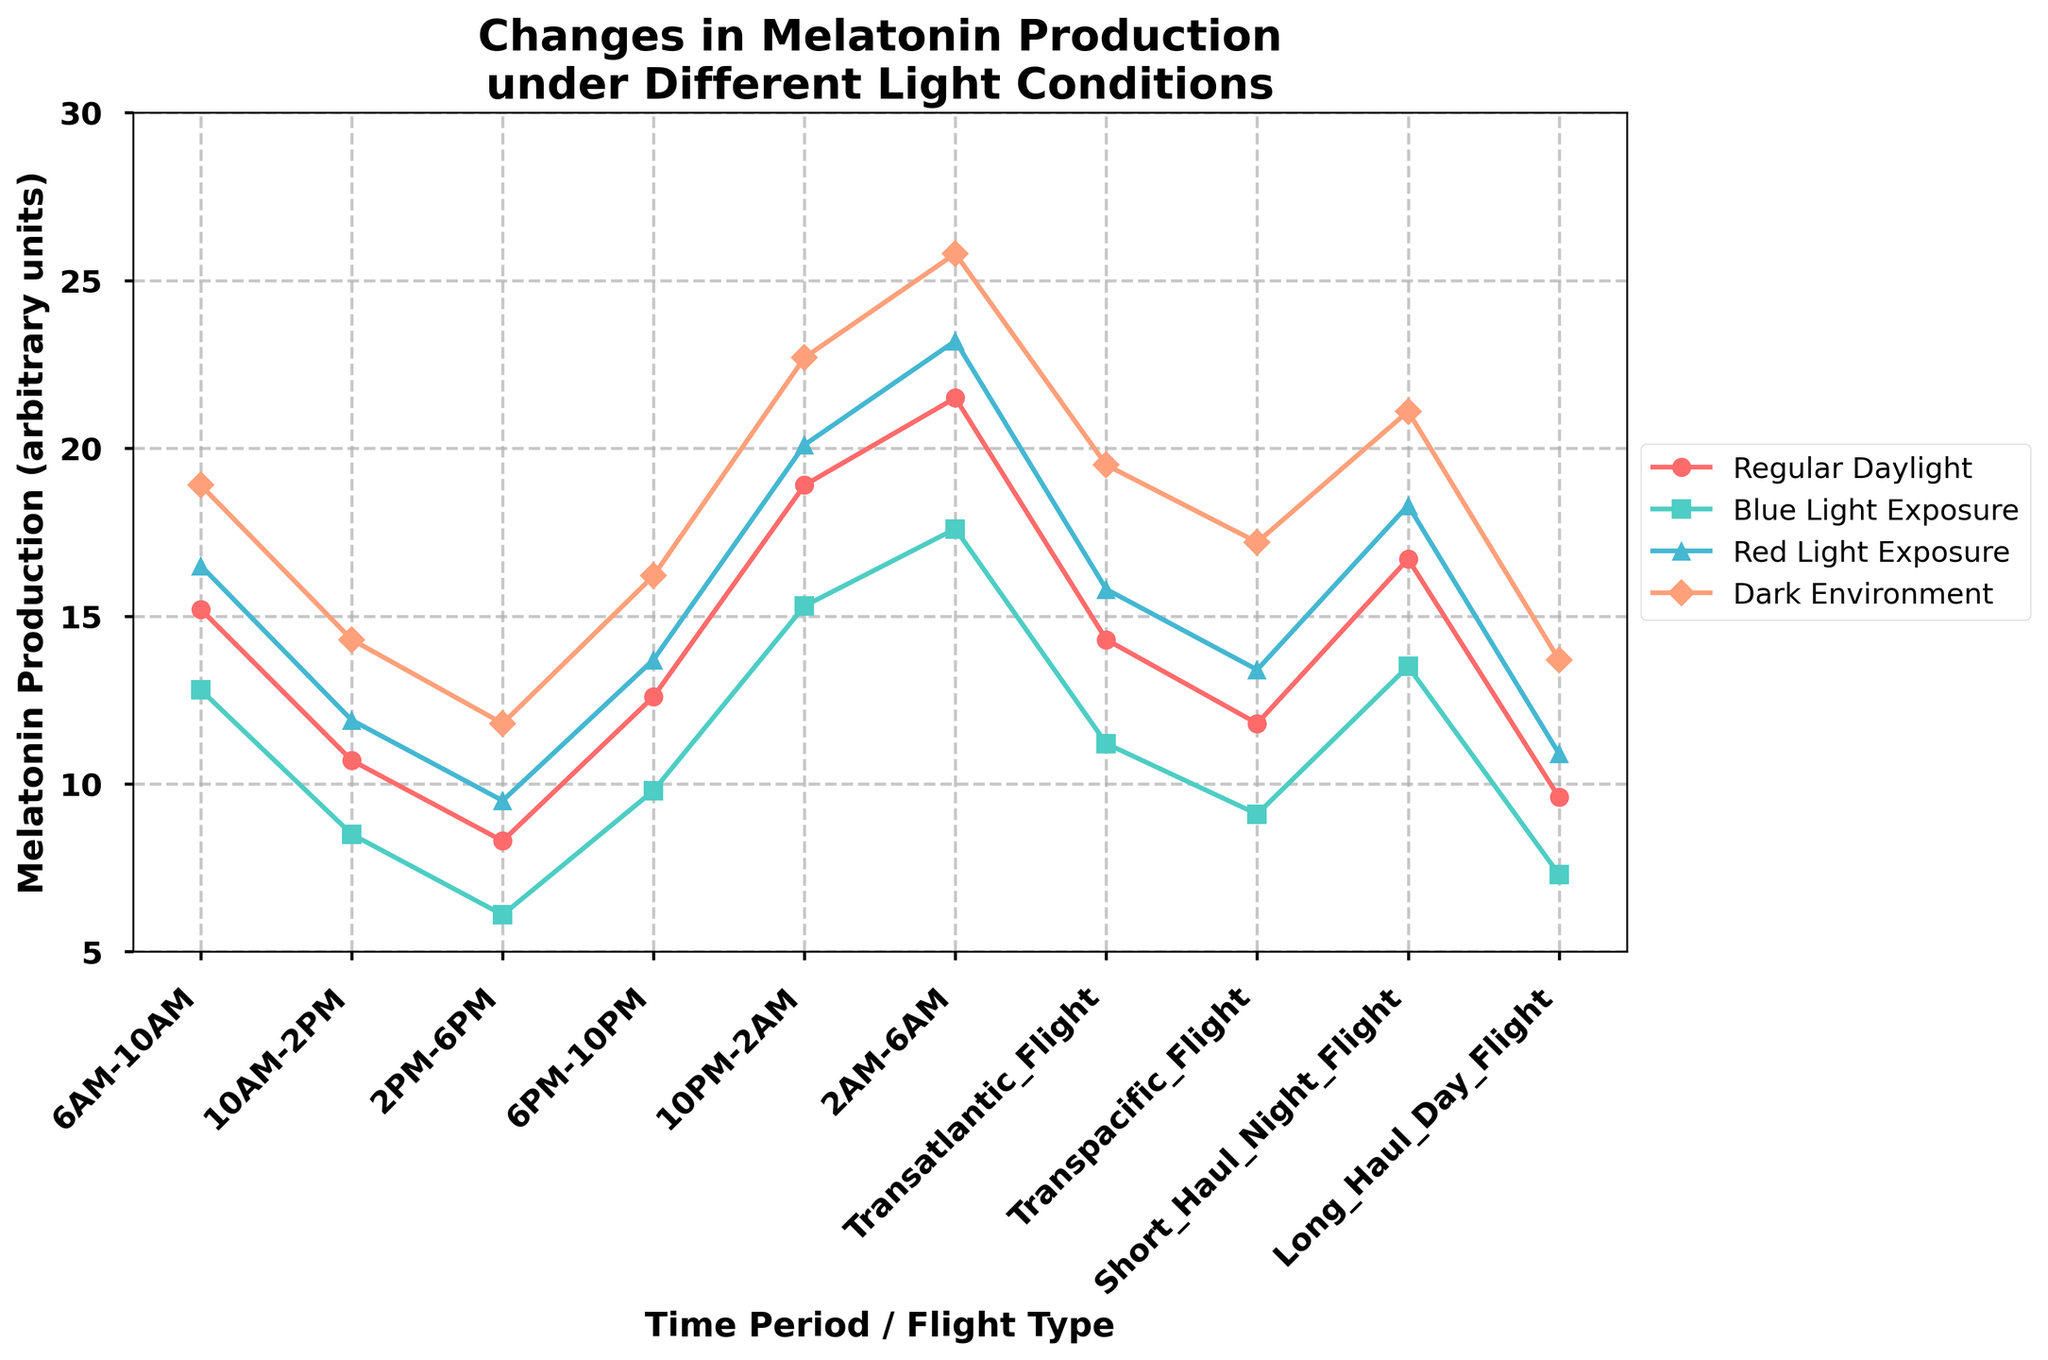Which light condition results in the highest melatonin production during the time period 2AM-6AM? We need to compare the melatonin production values for all light conditions during the 2AM-6AM period. Observing the graph, the highest melatonin production is in the Dark Environment condition, which is at 25.8 arbitrary units.
Answer: Dark Environment During the 6PM-10PM period, which light exposure has the lowest melatonin production? We need to look at the values for all light exposures during the 6PM-10PM period and identify the lowest one. From the graph, Blue Light Exposure shows the lowest melatonin production at 9.8 arbitrary units.
Answer: Blue Light Exposure What is the difference in melatonin production between Regular Daylight and Red Light Exposure during the Transatlantic Flight? Subtract the melatonin production for Regular Daylight from that of Red Light Exposure during the Transatlantic Flight. This is 15.8 (Red Light Exposure) - 14.3 (Regular Daylight) = 1.5.
Answer: 1.5 Compare the melatonin production for Regular Daylight and Dark Environment during the 10PM-2AM period. Which is higher, and by how much? The melatonin production during the 10PM-2AM period is 18.9 for Regular Daylight and 22.7 for Dark Environment. Dark Environment is higher by 22.7 - 18.9 = 3.8.
Answer: Dark Environment, by 3.8 What is the average melatonin production for Blue Light Exposure across all given flight schedules (Transatlantic Flight, Transpacific Flight, Short Haul Night Flight, Long Haul Day Flight)? Sum the melatonin production values for Blue Light Exposure across all flight schedules and divide by the number of schedules. (11.2 + 9.1 + 13.5 + 7.3) / 4 = 10.275.
Answer: 10.275 How does the melatonin production in a Dark Environment at 10AM-2PM compare with that of Regular Daylight at 6PM-10PM? The melatonin production in a Dark Environment at 10AM-2PM is 14.3, while for Regular Daylight at 6PM-10PM, it is 12.6. Dark Environment at 10AM-2PM is higher by 14.3 - 12.6 = 1.7.
Answer: Higher by 1.7 What is the total melatonin production across all time periods for Red Light Exposure? Add the melatonin production values for Red Light Exposure across all time periods. 16.5 + 11.9 + 9.5 + 13.7 + 20.1 + 23.2 = 94.9.
Answer: 94.9 During the Short Haul Night Flight, which light condition shows the closest melatonin production to Regular Daylight at the same time? The melatonin production for Regular Daylight during the Short Haul Night Flight is 16.7. Compare this with other light exposures: 13.5 (Blue Light Exposure), 18.3 (Red Light Exposure), 21.1 (Dark Environment). The closest is Red Light Exposure at 18.3.
Answer: Red Light Exposure What light condition leads to the maximum drop in melatonin production between 2AM-6AM and 10AM-2PM? Calculate the drop in melatonin production for each light condition between 2AM-6AM and 10AM-2PM. Regular Daylight: 21.5 - 10.7 = 10.8; Blue Light Exposure: 17.6 - 8.5 = 9.1; Red Light Exposure: 23.2 - 11.9 = 11.3; Dark Environment: 25.8 - 14.3 = 11.5. The maximum drop is in Dark Environment with 11.5.
Answer: Dark Environment, 11.5 